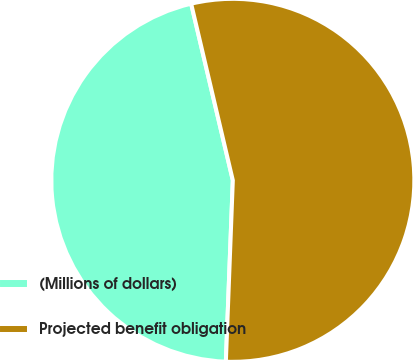Convert chart to OTSL. <chart><loc_0><loc_0><loc_500><loc_500><pie_chart><fcel>(Millions of dollars)<fcel>Projected benefit obligation<nl><fcel>45.7%<fcel>54.3%<nl></chart> 